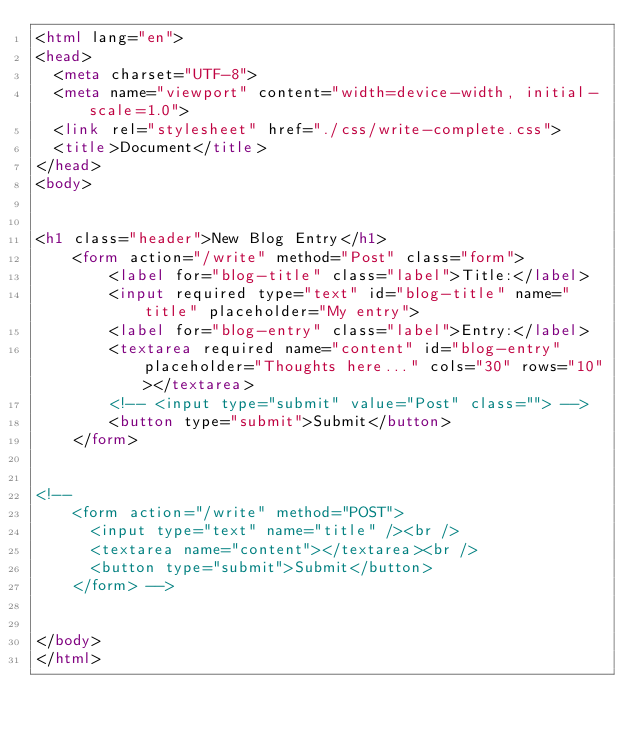<code> <loc_0><loc_0><loc_500><loc_500><_HTML_><html lang="en">
<head>
  <meta charset="UTF-8">
  <meta name="viewport" content="width=device-width, initial-scale=1.0">
  <link rel="stylesheet" href="./css/write-complete.css">
  <title>Document</title>
</head>
<body>


<h1 class="header">New Blog Entry</h1>
    <form action="/write" method="Post" class="form">
        <label for="blog-title" class="label">Title:</label>
        <input required type="text" id="blog-title" name="title" placeholder="My entry">
        <label for="blog-entry" class="label">Entry:</label>
        <textarea required name="content" id="blog-entry" placeholder="Thoughts here..." cols="30" rows="10"></textarea>
        <!-- <input type="submit" value="Post" class=""> -->
        <button type="submit">Submit</button>
    </form>
  

<!-- 
    <form action="/write" method="POST">
      <input type="text" name="title" /><br />
      <textarea name="content"></textarea><br />
      <button type="submit">Submit</button>
    </form> -->


</body>
</html>



</code> 